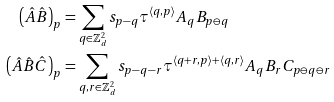<formula> <loc_0><loc_0><loc_500><loc_500>\left ( \hat { A } \hat { B } \right ) _ { p } & = \sum _ { q \in \mathbb { Z } _ { d } ^ { 2 } } s _ { p - q } \tau ^ { \langle q , p \rangle } A _ { q } B _ { p \ominus q } \\ \left ( \hat { A } \hat { B } \hat { C } \right ) _ { p } & = \sum _ { q , r \in \mathbb { Z } ^ { 2 } _ { d } } s _ { p - q - r } \tau ^ { \langle q + r , p \rangle + \langle q , r \rangle } A _ { q } B _ { r } C _ { p \ominus q \ominus r }</formula> 